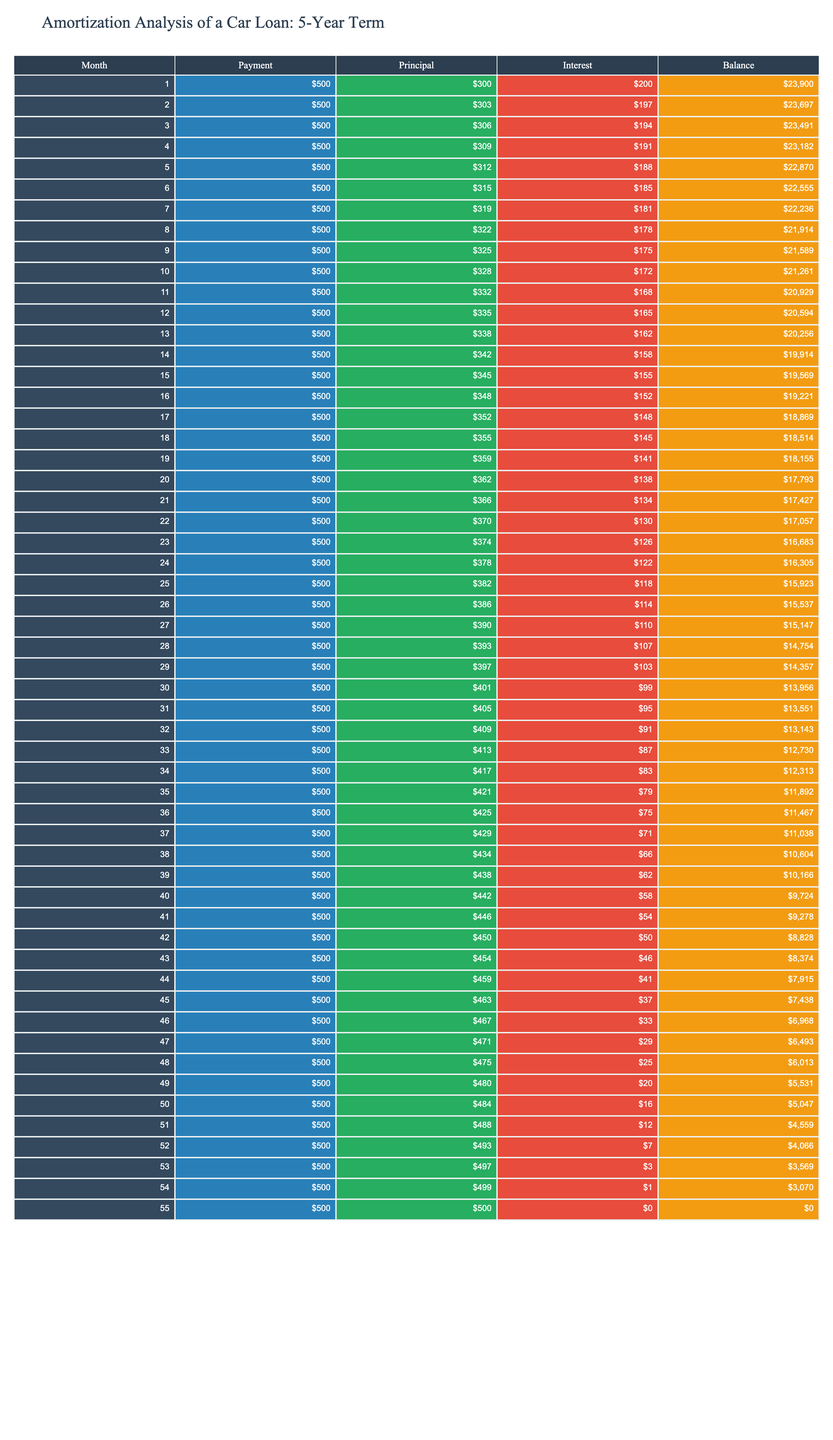What is the payment amount in the first month? The first month's payment is specified in the table under the Payment column, which shows 500.
Answer: 500 What is the total principal paid after the first three months? To find the total principal paid after three months, we add the Principal values for the first three months: 300 + 303 + 306 = 909.
Answer: 909 How much interest is paid in the 12th month? The interest paid in the 12th month can be found directly in the Interest column of the table, which shows 165.
Answer: 165 What is the remaining balance after 24 months? The remaining balance after 24 months is found in the Balance column for the 24th month, which is 16305.
Answer: 16305 Is the amount paid towards interest higher in the first month than in the last month? The interest paid in the first month is 200, and in the last month, it is 0. Since 200 is greater than 0, the statement is true.
Answer: Yes What is the average amount of interest paid in the first half of the loan term (first 30 months)? To calculate the average interest for the first half, we sum the Interest values for the first 30 months: (200 + 197 + 194 + 191 + ... + 99) = 4725, then divide by 30, resulting in an average of 157.5.
Answer: 157.5 How does the principal payment in the last month compare to the principal payment in the first month? In the first month, the principal payment is 300, while in the last month it is 500. 500 is greater than 300, indicating an increase.
Answer: Increased What is the total amount paid in the last year (months 49 to 55)? To find the total amount paid from month 49 to month 55, we sum the Payment values for these months: (500 * 7) = 3500.
Answer: 3500 In which month does the interest payment fall below 100? From examining the Interest column, we can see that in the 30th month, the interest payment falls to 99.
Answer: Month 30 